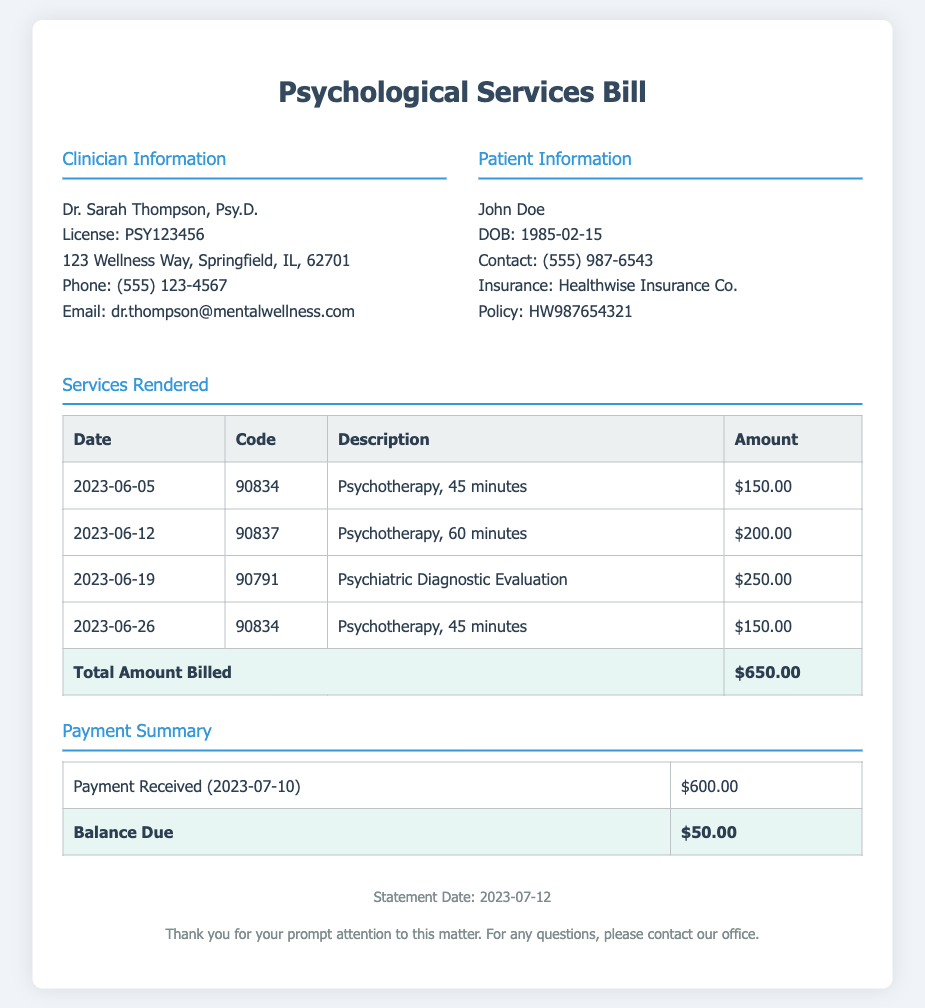What is the clinician's name? The clinician's name is stated in the clinician information section.
Answer: Dr. Sarah Thompson What is the date of the first patient visit? The first patient visit date is listed in the services rendered table.
Answer: 2023-06-05 What is the total amount billed? The total amount billed is shown at the bottom of the services rendered table.
Answer: $650.00 How much was the payment received? The payment received is mentioned in the payment summary section.
Answer: $600.00 What is the balance due? The balance due is indicated at the end of the payment summary table.
Answer: $50.00 What was the billing code for the psychiatric diagnostic evaluation? The billing code can be found in the services rendered table for that specific service.
Answer: 90791 How many psychotherapy sessions were rendered? The number of psychotherapy sessions is calculated from the services rendered table entries that include psychotherapy.
Answer: 3 What is the description of the service on June 12? The description for the service can be found next to the date in the services rendered table.
Answer: Psychotherapy, 60 minutes What insurance company is listed on the patient's information? The insurance company name is provided in the patient information section.
Answer: Healthwise Insurance Co 